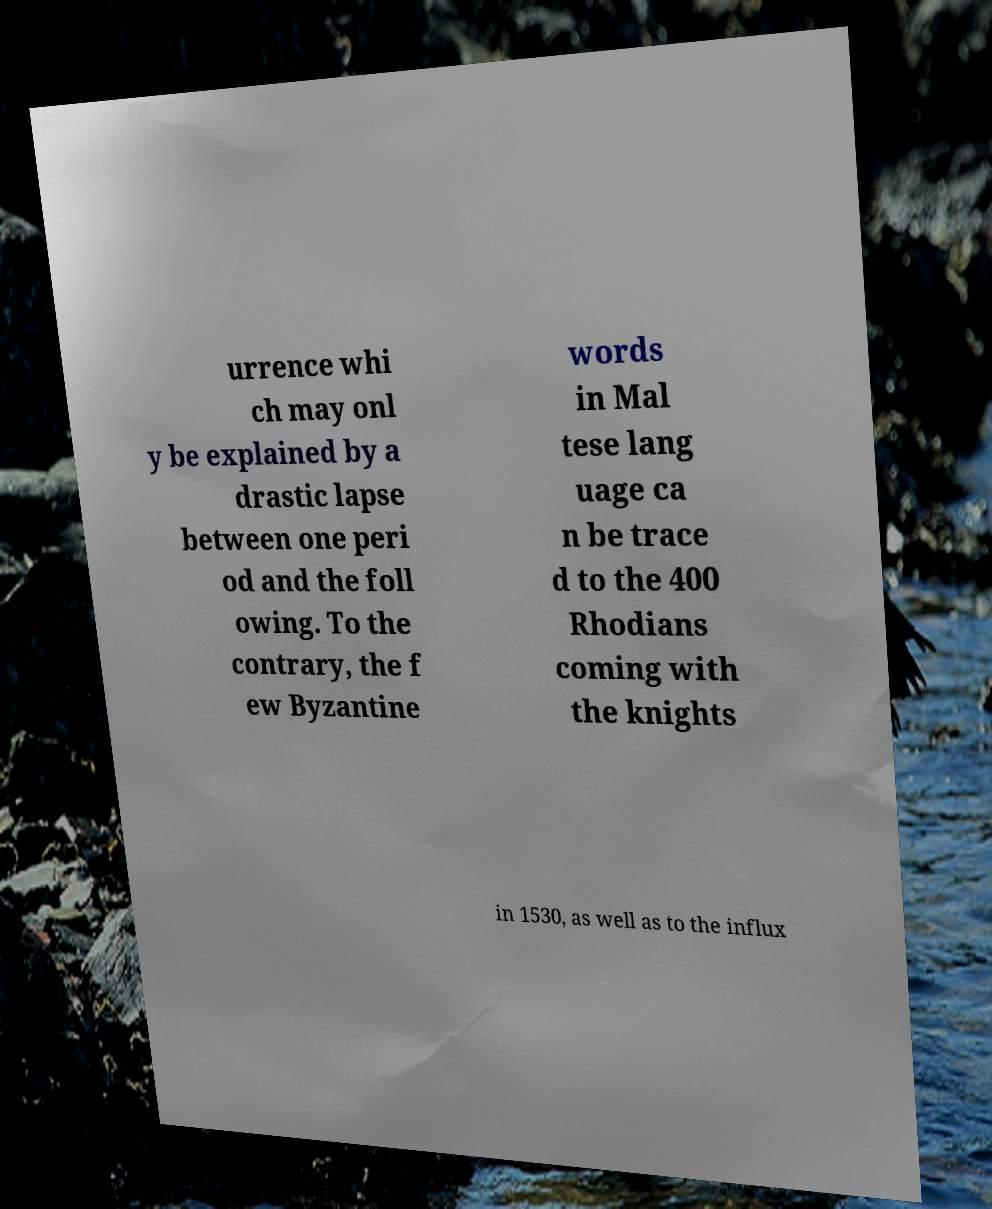Could you assist in decoding the text presented in this image and type it out clearly? urrence whi ch may onl y be explained by a drastic lapse between one peri od and the foll owing. To the contrary, the f ew Byzantine words in Mal tese lang uage ca n be trace d to the 400 Rhodians coming with the knights in 1530, as well as to the influx 